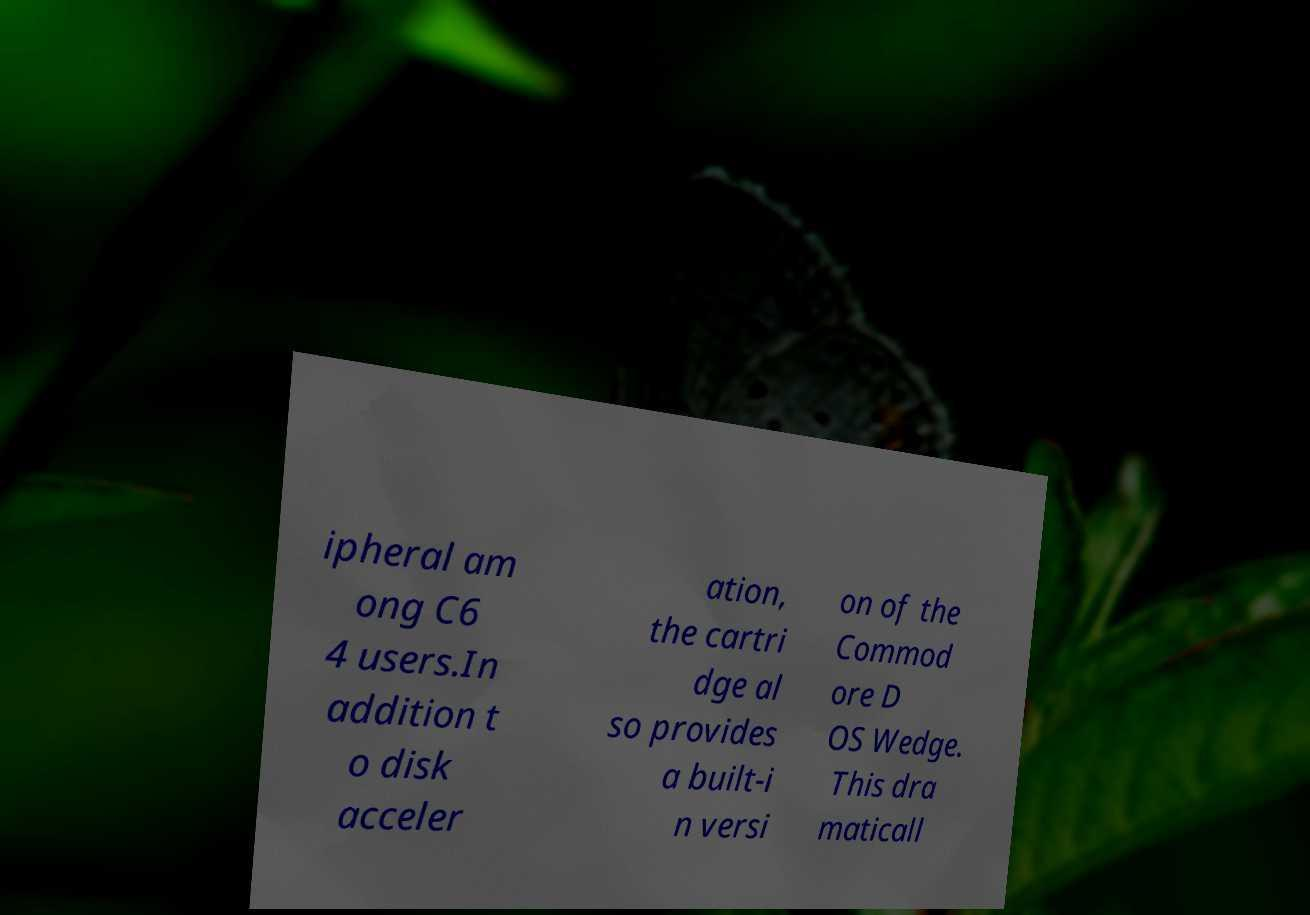I need the written content from this picture converted into text. Can you do that? ipheral am ong C6 4 users.In addition t o disk acceler ation, the cartri dge al so provides a built-i n versi on of the Commod ore D OS Wedge. This dra maticall 